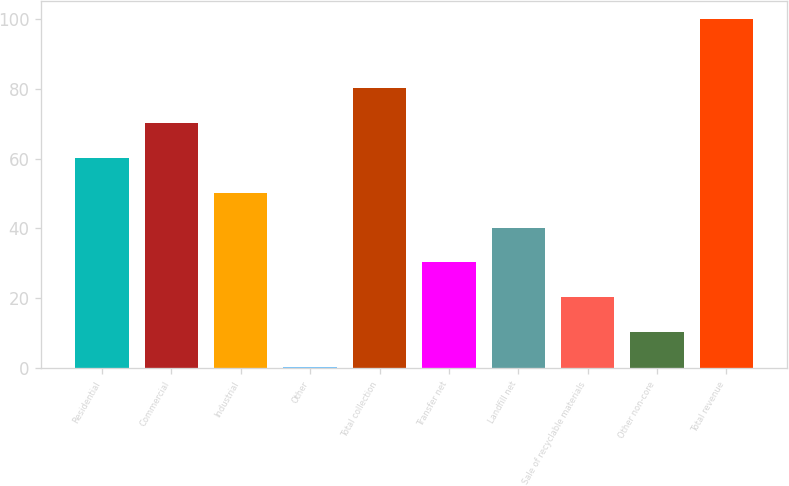<chart> <loc_0><loc_0><loc_500><loc_500><bar_chart><fcel>Residential<fcel>Commercial<fcel>Industrial<fcel>Other<fcel>Total collection<fcel>Transfer net<fcel>Landfill net<fcel>Sale of recyclable materials<fcel>Other non-core<fcel>Total revenue<nl><fcel>60.16<fcel>70.12<fcel>50.2<fcel>0.4<fcel>80.08<fcel>30.28<fcel>40.24<fcel>20.32<fcel>10.36<fcel>100<nl></chart> 